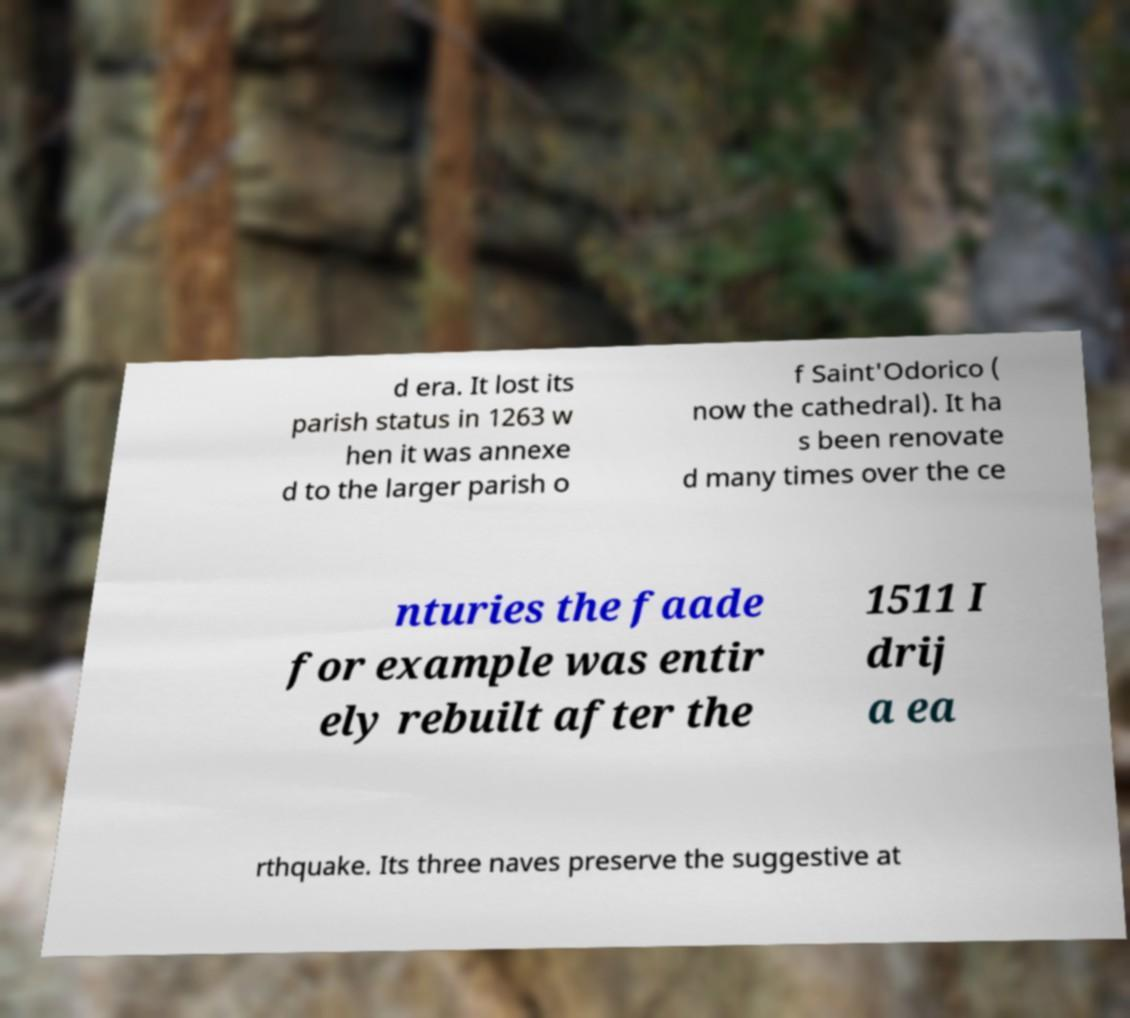What messages or text are displayed in this image? I need them in a readable, typed format. d era. It lost its parish status in 1263 w hen it was annexe d to the larger parish o f Saint'Odorico ( now the cathedral). It ha s been renovate d many times over the ce nturies the faade for example was entir ely rebuilt after the 1511 I drij a ea rthquake. Its three naves preserve the suggestive at 